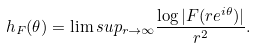Convert formula to latex. <formula><loc_0><loc_0><loc_500><loc_500>h _ { F } ( \theta ) = \lim s u p _ { r \to \infty } \frac { \log | F ( r e ^ { i \theta } ) | } { r ^ { 2 } } .</formula> 